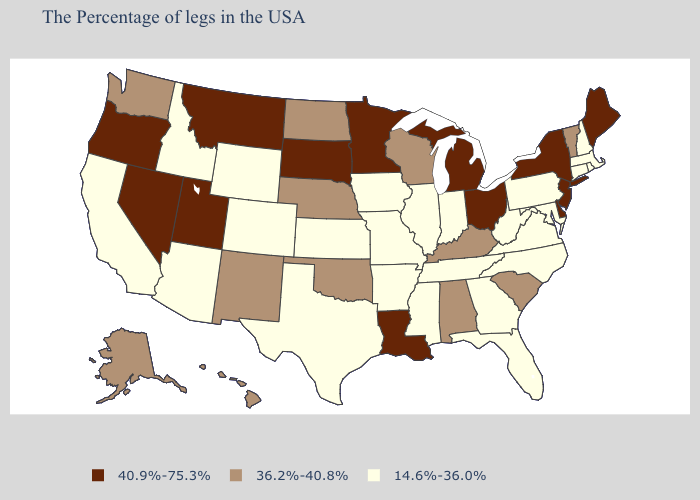Does Montana have the highest value in the USA?
Be succinct. Yes. What is the highest value in states that border Florida?
Concise answer only. 36.2%-40.8%. Name the states that have a value in the range 36.2%-40.8%?
Write a very short answer. Vermont, South Carolina, Kentucky, Alabama, Wisconsin, Nebraska, Oklahoma, North Dakota, New Mexico, Washington, Alaska, Hawaii. What is the value of Iowa?
Concise answer only. 14.6%-36.0%. What is the value of Idaho?
Write a very short answer. 14.6%-36.0%. Name the states that have a value in the range 36.2%-40.8%?
Write a very short answer. Vermont, South Carolina, Kentucky, Alabama, Wisconsin, Nebraska, Oklahoma, North Dakota, New Mexico, Washington, Alaska, Hawaii. Does Maine have the lowest value in the Northeast?
Concise answer only. No. Which states hav the highest value in the West?
Quick response, please. Utah, Montana, Nevada, Oregon. Name the states that have a value in the range 36.2%-40.8%?
Write a very short answer. Vermont, South Carolina, Kentucky, Alabama, Wisconsin, Nebraska, Oklahoma, North Dakota, New Mexico, Washington, Alaska, Hawaii. What is the lowest value in the West?
Quick response, please. 14.6%-36.0%. How many symbols are there in the legend?
Concise answer only. 3. Which states hav the highest value in the Northeast?
Keep it brief. Maine, New York, New Jersey. Does Pennsylvania have the lowest value in the Northeast?
Concise answer only. Yes. What is the value of New Mexico?
Keep it brief. 36.2%-40.8%. What is the lowest value in states that border Montana?
Give a very brief answer. 14.6%-36.0%. 